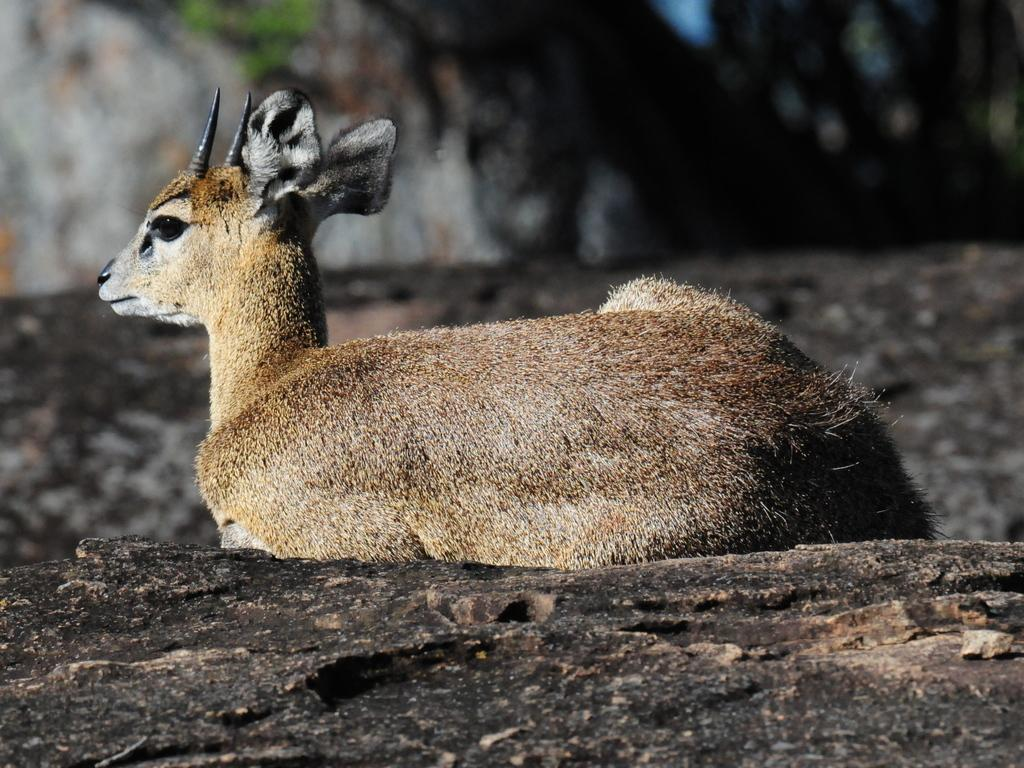What type of animal is in the image? The animal in the image has brown, white, and black coloring, but the specific type of animal cannot be determined from the provided facts. What is the animal resting on in the image? The animal is lying on a rocky surface. What colors are present on the rocky surface? The rocky surface has black and brown colors. How would you describe the background of the image? The background of the image is blurry. What type of notebook is the animal using to write in the image? There is no notebook present in the image, and the animal is not shown engaging in any writing activity. 